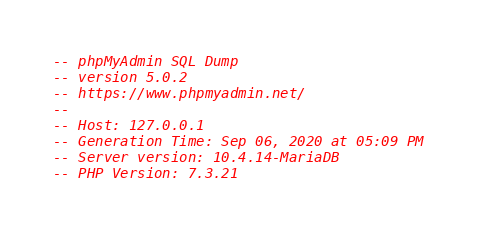<code> <loc_0><loc_0><loc_500><loc_500><_SQL_>-- phpMyAdmin SQL Dump
-- version 5.0.2
-- https://www.phpmyadmin.net/
--
-- Host: 127.0.0.1
-- Generation Time: Sep 06, 2020 at 05:09 PM
-- Server version: 10.4.14-MariaDB
-- PHP Version: 7.3.21
</code> 